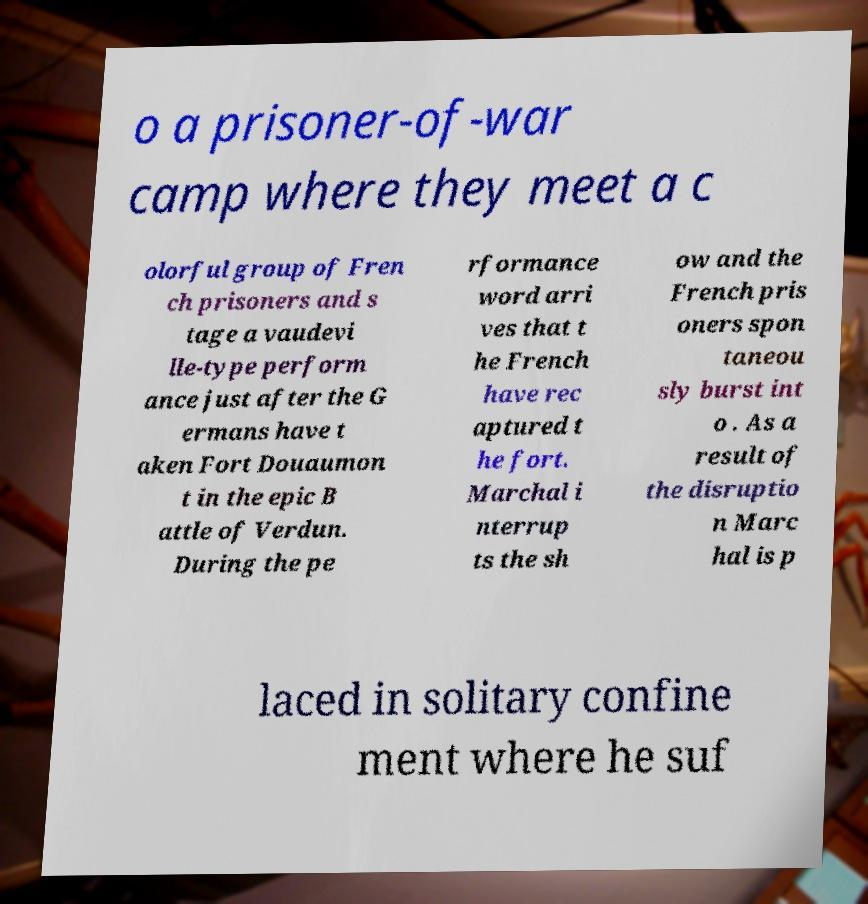What messages or text are displayed in this image? I need them in a readable, typed format. o a prisoner-of-war camp where they meet a c olorful group of Fren ch prisoners and s tage a vaudevi lle-type perform ance just after the G ermans have t aken Fort Douaumon t in the epic B attle of Verdun. During the pe rformance word arri ves that t he French have rec aptured t he fort. Marchal i nterrup ts the sh ow and the French pris oners spon taneou sly burst int o . As a result of the disruptio n Marc hal is p laced in solitary confine ment where he suf 